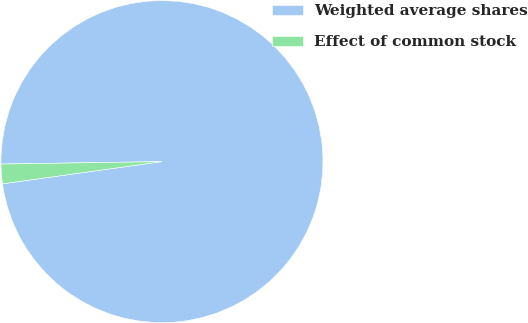Convert chart to OTSL. <chart><loc_0><loc_0><loc_500><loc_500><pie_chart><fcel>Weighted average shares<fcel>Effect of common stock<nl><fcel>98.04%<fcel>1.96%<nl></chart> 